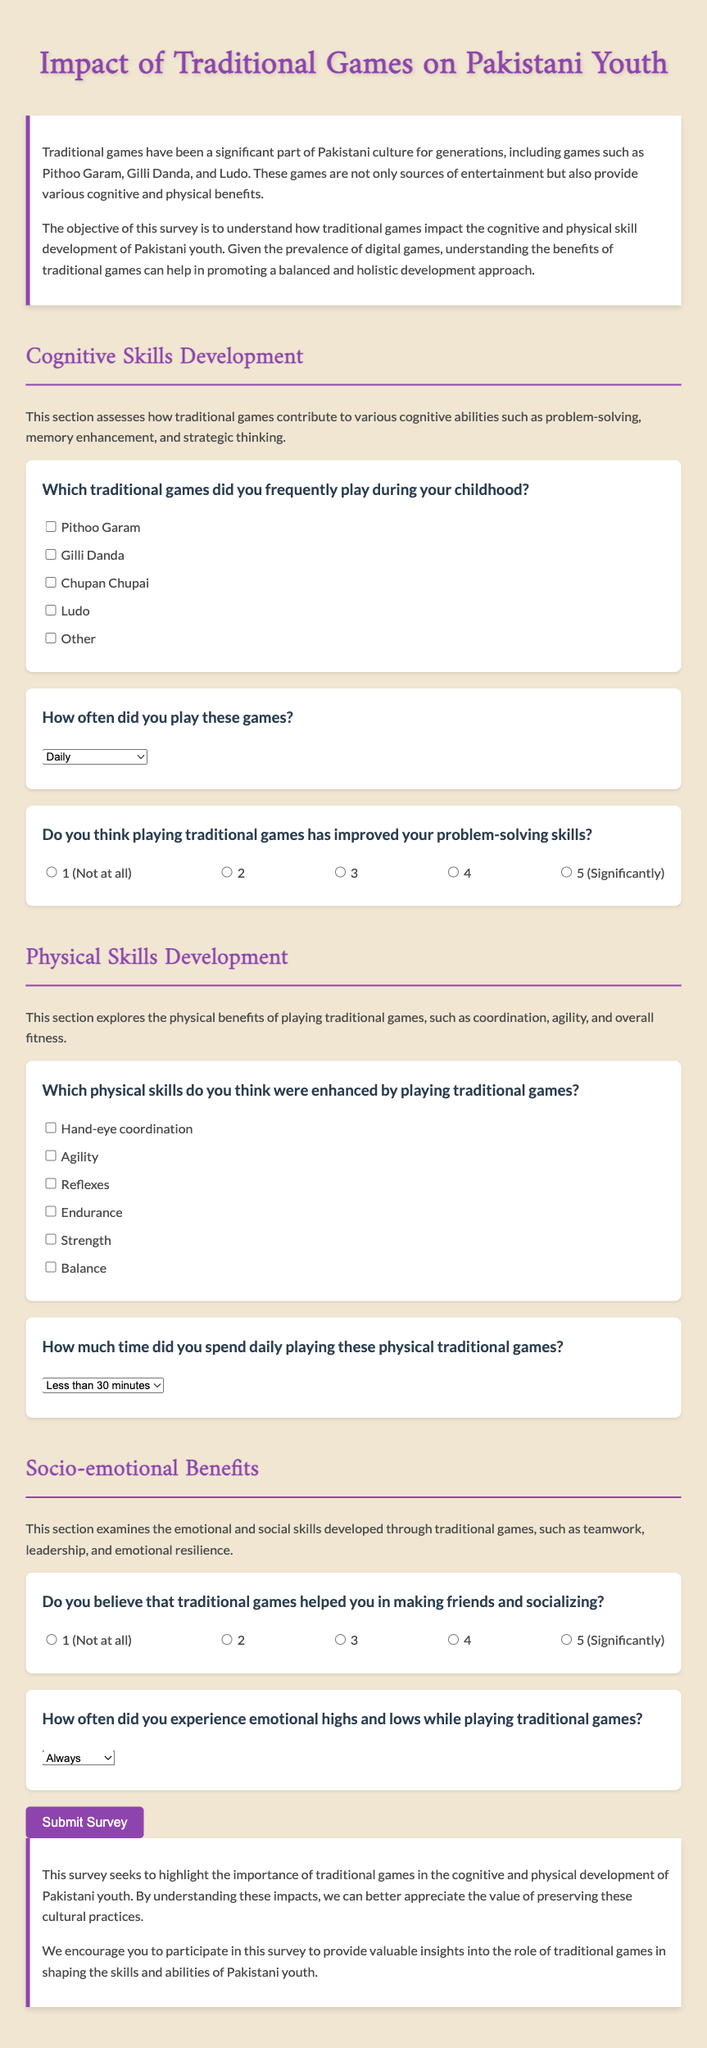Which games are mentioned in the survey? The survey lists several traditional games such as Pithoo Garam, Gilli Danda, Chupan Chupai, and Ludo.
Answer: Pithoo Garam, Gilli Danda, Chupan Chupai, Ludo How often can participants select for the frequency of playing traditional games? The survey provides multiple options for how often participants played, such as daily and weekly.
Answer: Daily, few times a week, weekly, rarely, never What skill is primarily assessed in the first cognitive skills question? The first cognitive skills question specifically assesses improvements in problem-solving skills due to traditional games.
Answer: Problem-solving skills What physical skill is mentioned regarding coordination? The survey asks about the enhancement of hand-eye coordination as a physical skill developed through traditional games.
Answer: Hand-eye coordination How many response options are provided for the question about socializing? For the socializing question, there are five response options for participants to choose from regarding their experiences.
Answer: Five What is the purpose of the survey? The objective of the survey is to understand how traditional games impact the cognitive and physical skill development of Pakistani youth.
Answer: Understand impact on cognitive and physical skills What is the maximum duration mentioned for playing traditional games in a day? The survey includes a response option to indicate playing traditional games for more than two hours daily.
Answer: More than 2 hours What kind of benefits are examined in the socio-emotional benefits section? This section examines emotional and social skills developed through traditional games, such as teamwork and resilience.
Answer: Teamwork, leadership, emotional resilience 